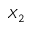<formula> <loc_0><loc_0><loc_500><loc_500>X _ { 2 }</formula> 